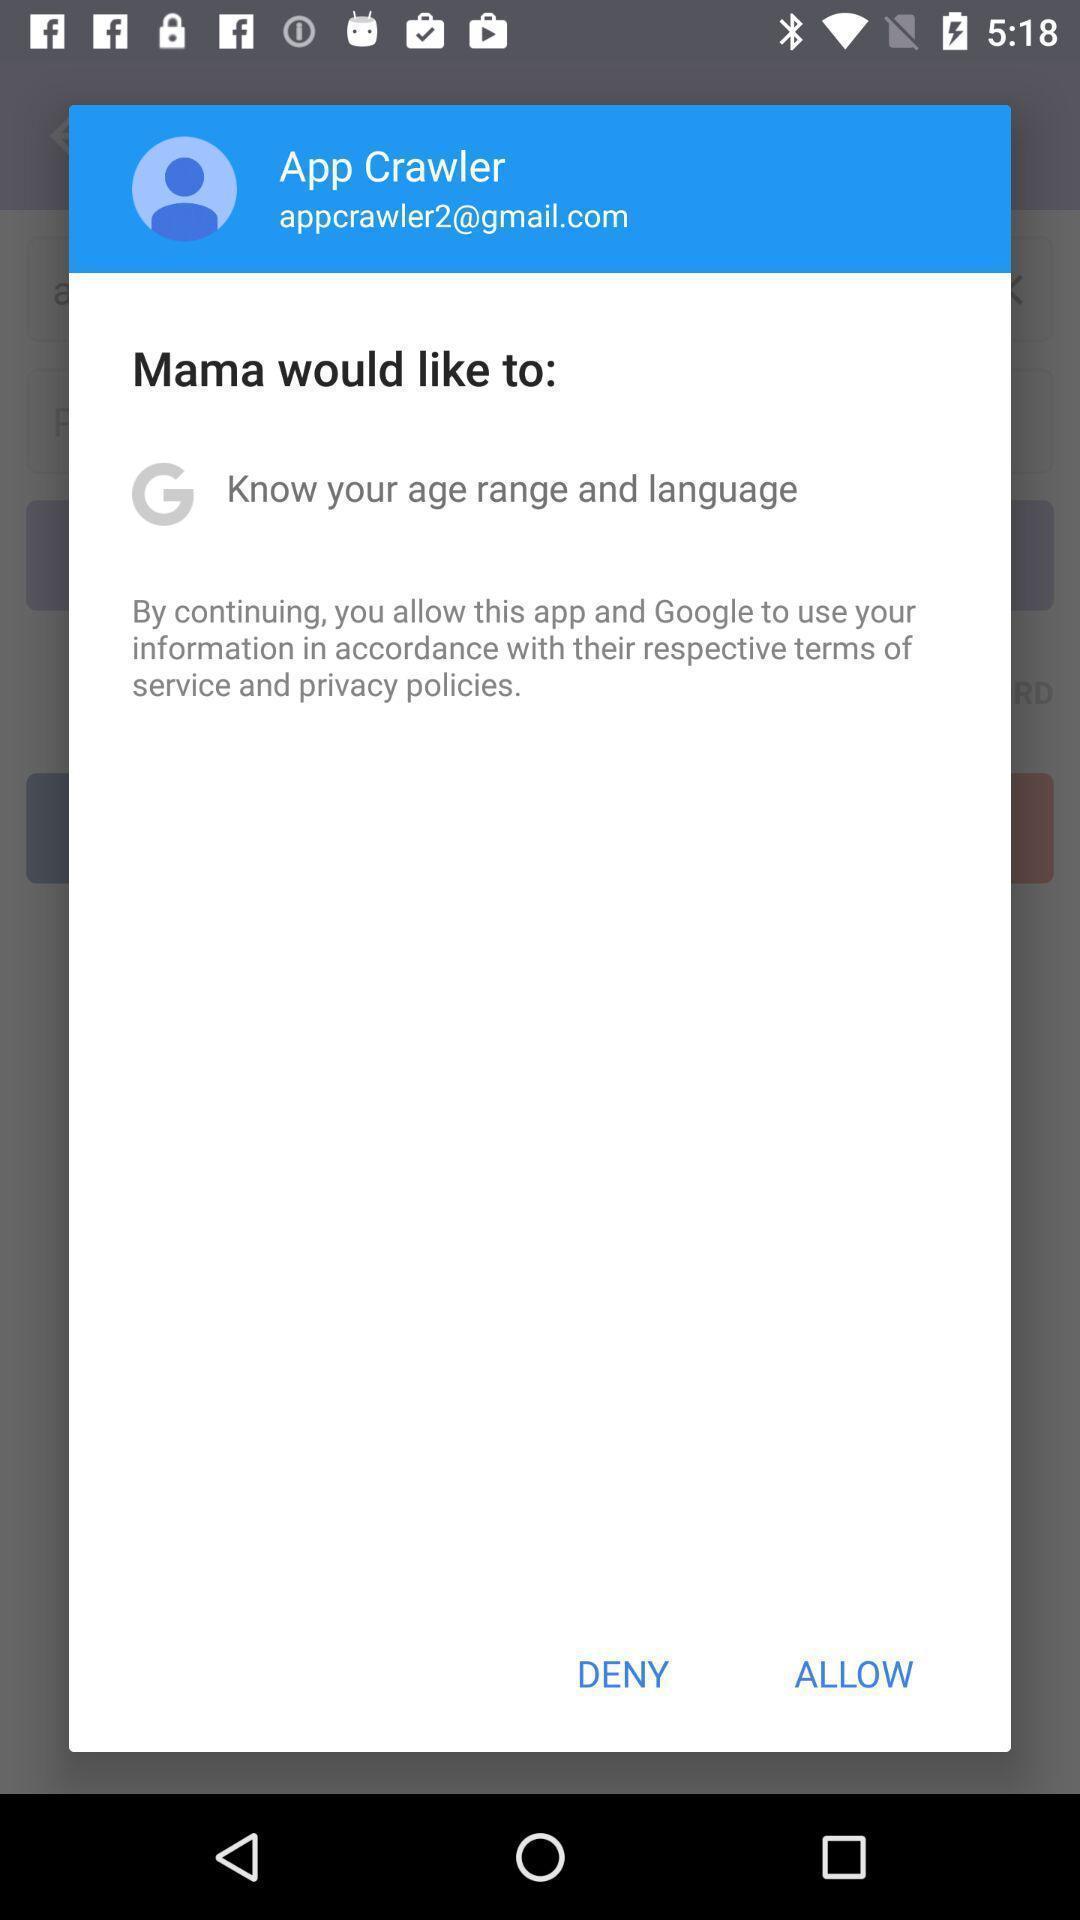Give me a summary of this screen capture. Popup page for allowing terms and policies. 